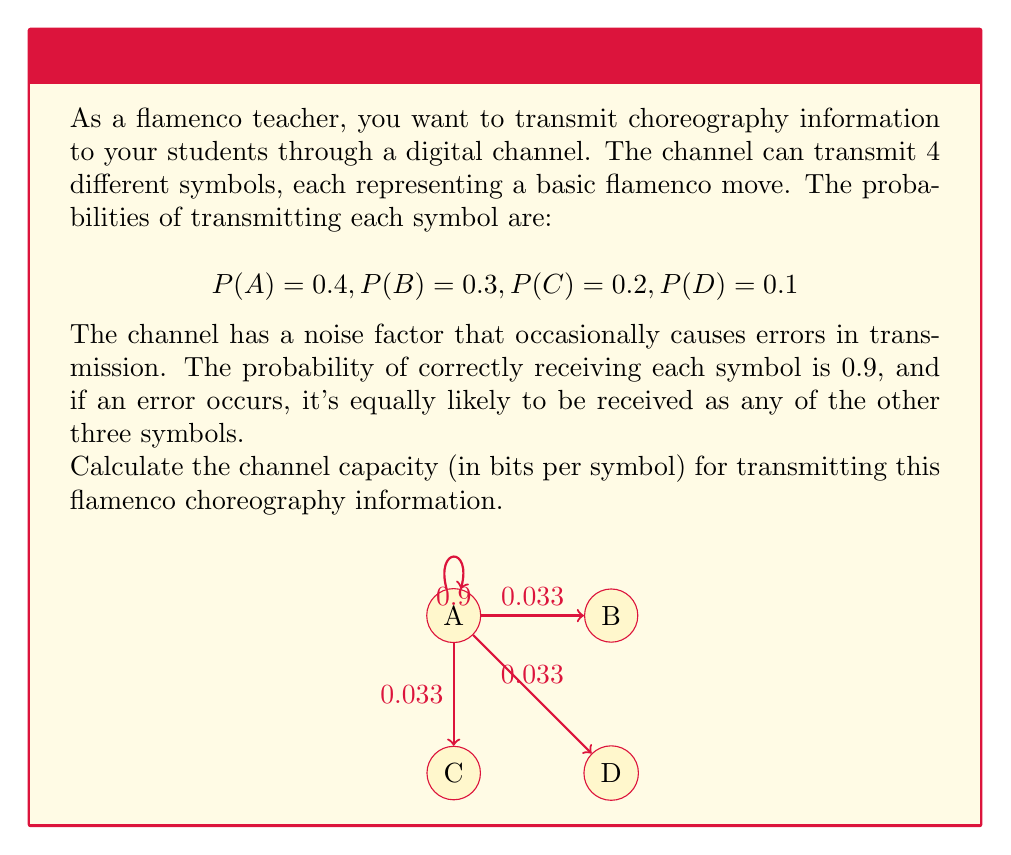Show me your answer to this math problem. To calculate the channel capacity, we need to follow these steps:

1) First, we need to calculate the entropy of the input, H(X):

$$H(X) = -\sum_{i} P(X_i) \log_2 P(X_i)$$
$$H(X) = -(0.4 \log_2 0.4 + 0.3 \log_2 0.3 + 0.2 \log_2 0.2 + 0.1 \log_2 0.1)$$
$$H(X) \approx 1.8464 \text{ bits}$$

2) Next, we need to calculate the conditional entropy H(Y|X), which represents the uncertainty of the output given the input:

For each symbol, there's a 0.9 probability of correct transmission and 0.1 probability of error (equally distributed among the other 3 symbols, so 0.0333 each).

$$H(Y|X) = -\sum_{i} P(X_i) \sum_{j} P(Y_j|X_i) \log_2 P(Y_j|X_i)$$
$$H(Y|X) = -(0.9 \log_2 0.9 + 3 * 0.0333 \log_2 0.0333)$$
$$H(Y|X) \approx 0.3488 \text{ bits}$$

3) Now we can calculate the mutual information I(X;Y):

$$I(X;Y) = H(X) - H(Y|X)$$
$$I(X;Y) = 1.8464 - 0.3488 = 1.4976 \text{ bits}$$

4) The channel capacity is the maximum mutual information over all possible input distributions. In this case, we've already been given the input distribution, so the calculated mutual information is the channel capacity.

Therefore, the channel capacity is approximately 1.4976 bits per symbol.
Answer: 1.4976 bits/symbol 